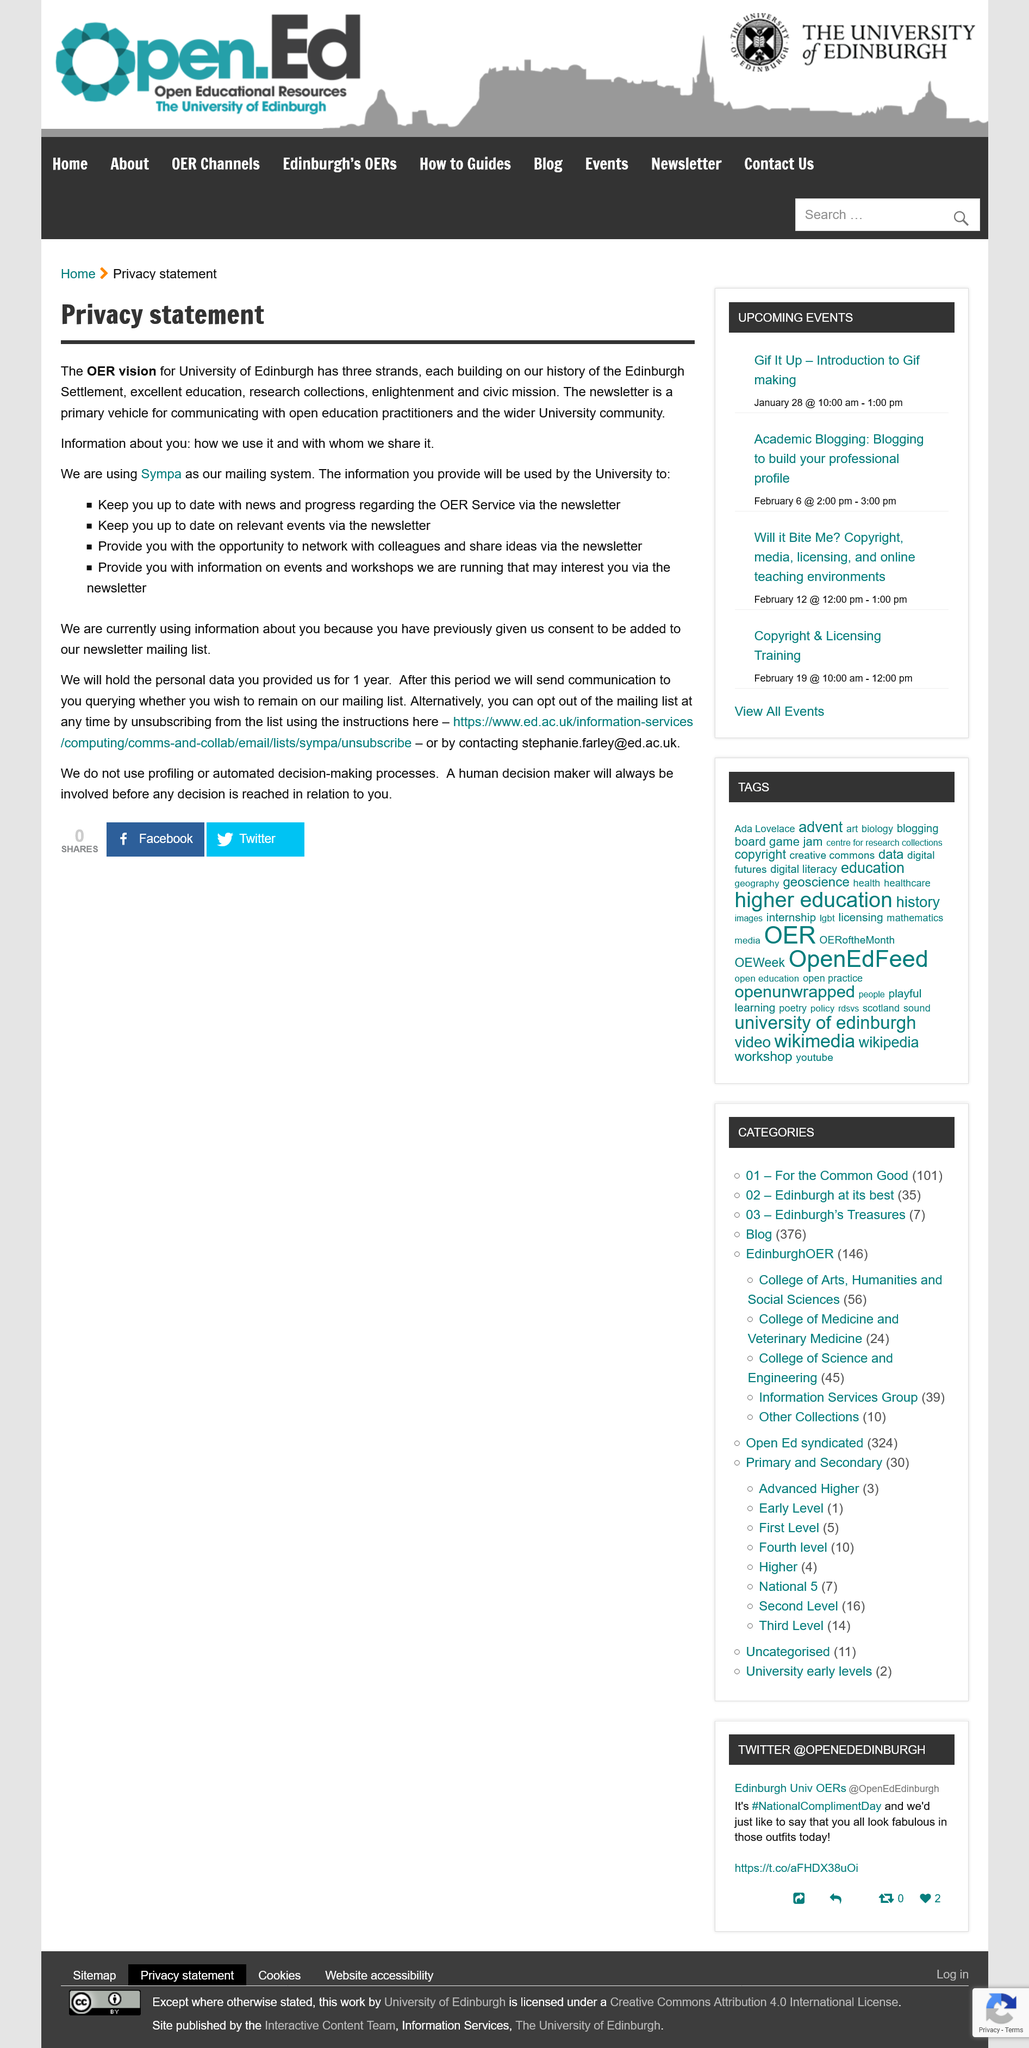Point out several critical features in this image. The University of Edinburgh will retain your data for a period of 1 year. The University of Edinburgh's Open Educational Resources (OER) vision has three strands. 